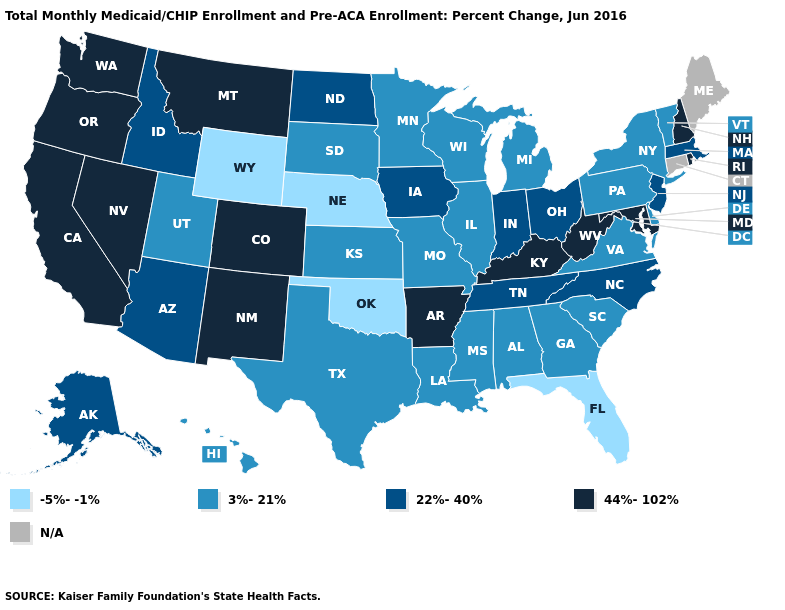Does the first symbol in the legend represent the smallest category?
Quick response, please. Yes. What is the value of Maine?
Give a very brief answer. N/A. What is the value of Hawaii?
Keep it brief. 3%-21%. How many symbols are there in the legend?
Quick response, please. 5. Name the states that have a value in the range -5%--1%?
Give a very brief answer. Florida, Nebraska, Oklahoma, Wyoming. What is the lowest value in states that border Tennessee?
Short answer required. 3%-21%. What is the value of Michigan?
Short answer required. 3%-21%. What is the value of Idaho?
Give a very brief answer. 22%-40%. Name the states that have a value in the range N/A?
Be succinct. Connecticut, Maine. What is the value of Connecticut?
Write a very short answer. N/A. Which states hav the highest value in the MidWest?
Concise answer only. Indiana, Iowa, North Dakota, Ohio. Does the first symbol in the legend represent the smallest category?
Be succinct. Yes. Does Maryland have the highest value in the USA?
Answer briefly. Yes. Does the map have missing data?
Be succinct. Yes. 